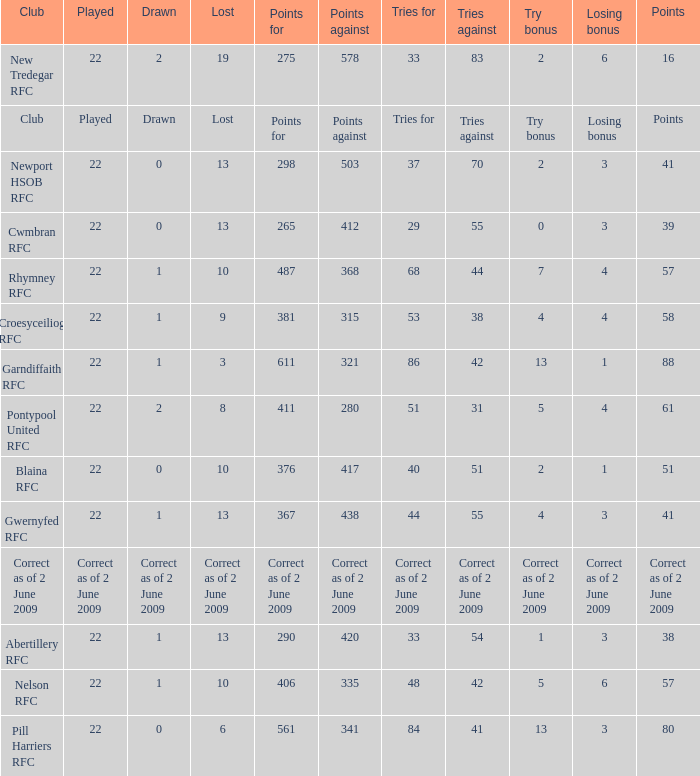How many points against did the club with a losing bonus of 3 and 84 tries have? 341.0. 